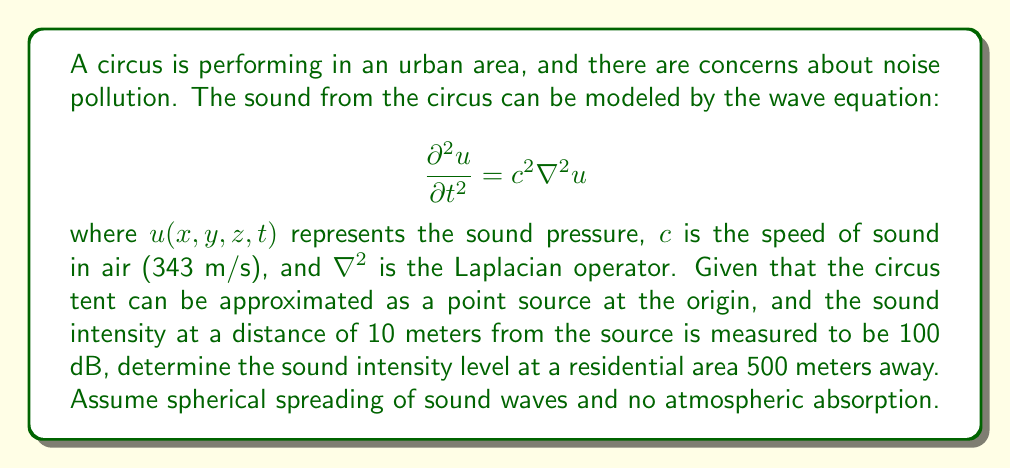Help me with this question. Let's approach this step-by-step:

1) The intensity of sound $I$ is inversely proportional to the square of the distance $r$ from a point source in a free field:

   $$I \propto \frac{1}{r^2}$$

2) Let $I_1$ be the intensity at distance $r_1$, and $I_2$ be the intensity at distance $r_2$. We can write:

   $$\frac{I_1}{I_2} = \frac{r_2^2}{r_1^2}$$

3) The sound intensity level $L$ in decibels is related to intensity $I$ by:

   $$L = 10 \log_{10}\left(\frac{I}{I_0}\right)$$

   where $I_0$ is the reference intensity (10^-12 W/m^2).

4) Given: 
   - At $r_1 = 10$ m, $L_1 = 100$ dB
   - We need to find $L_2$ at $r_2 = 500$ m

5) First, let's find the ratio of intensities:

   $$\frac{I_2}{I_1} = \frac{r_1^2}{r_2^2} = \frac{10^2}{500^2} = \frac{1}{2500}$$

6) Now, we can relate this to the difference in decibel levels:

   $$L_2 - L_1 = 10 \log_{10}\left(\frac{I_2}{I_1}\right) = 10 \log_{10}\left(\frac{1}{2500}\right) = -10 \log_{10}(2500) \approx -34$$

7) Therefore:

   $$L_2 = L_1 - 34 = 100 - 34 = 66 \text{ dB}$$
Answer: 66 dB 